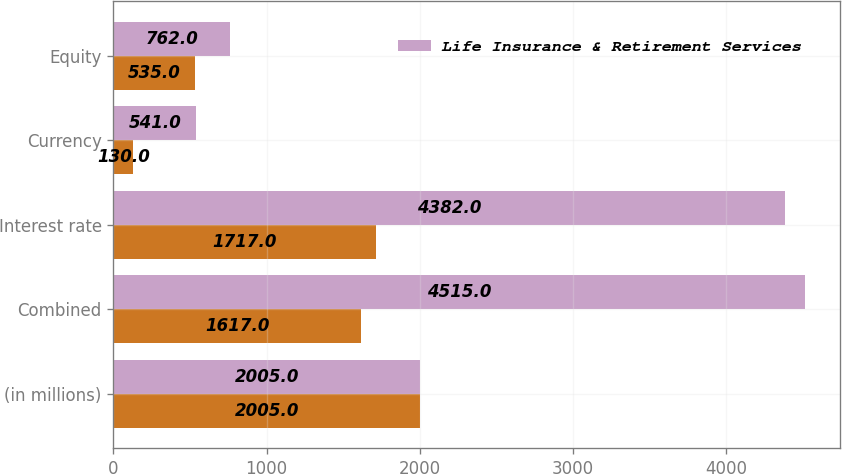<chart> <loc_0><loc_0><loc_500><loc_500><stacked_bar_chart><ecel><fcel>(in millions)<fcel>Combined<fcel>Interest rate<fcel>Currency<fcel>Equity<nl><fcel>nan<fcel>2005<fcel>1617<fcel>1717<fcel>130<fcel>535<nl><fcel>Life Insurance & Retirement Services<fcel>2005<fcel>4515<fcel>4382<fcel>541<fcel>762<nl></chart> 